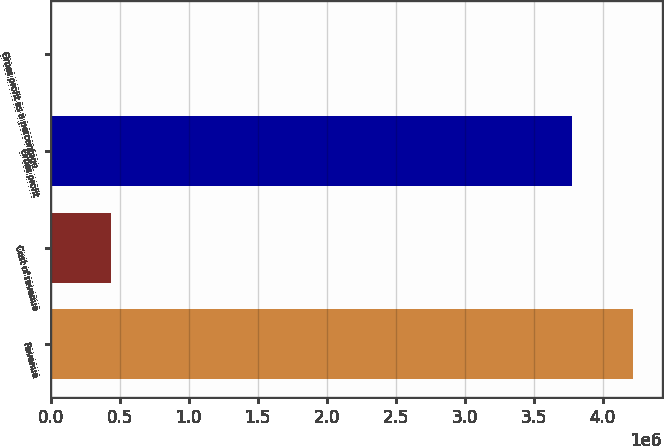Convert chart. <chart><loc_0><loc_0><loc_500><loc_500><bar_chart><fcel>Revenue<fcel>Cost of revenue<fcel>Gross profit<fcel>Gross profit as a percentage<nl><fcel>4.21626e+06<fcel>437873<fcel>3.77838e+06<fcel>90<nl></chart> 